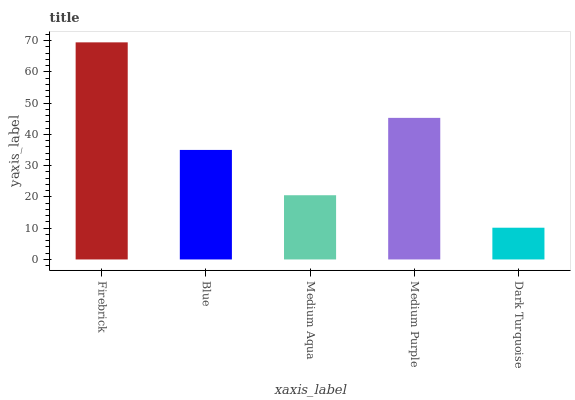Is Dark Turquoise the minimum?
Answer yes or no. Yes. Is Firebrick the maximum?
Answer yes or no. Yes. Is Blue the minimum?
Answer yes or no. No. Is Blue the maximum?
Answer yes or no. No. Is Firebrick greater than Blue?
Answer yes or no. Yes. Is Blue less than Firebrick?
Answer yes or no. Yes. Is Blue greater than Firebrick?
Answer yes or no. No. Is Firebrick less than Blue?
Answer yes or no. No. Is Blue the high median?
Answer yes or no. Yes. Is Blue the low median?
Answer yes or no. Yes. Is Medium Aqua the high median?
Answer yes or no. No. Is Medium Purple the low median?
Answer yes or no. No. 